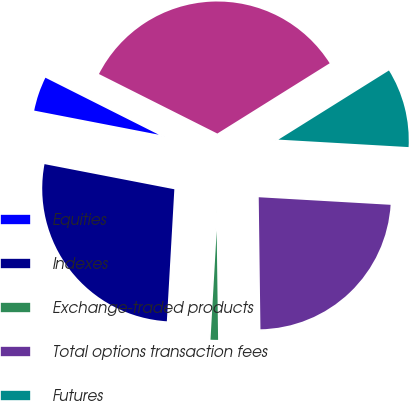Convert chart to OTSL. <chart><loc_0><loc_0><loc_500><loc_500><pie_chart><fcel>Equities<fcel>Indexes<fcel>Exchange-traded products<fcel>Total options transaction fees<fcel>Futures<fcel>Total transaction fees<nl><fcel>4.37%<fcel>27.14%<fcel>1.11%<fcel>23.88%<fcel>9.81%<fcel>33.69%<nl></chart> 